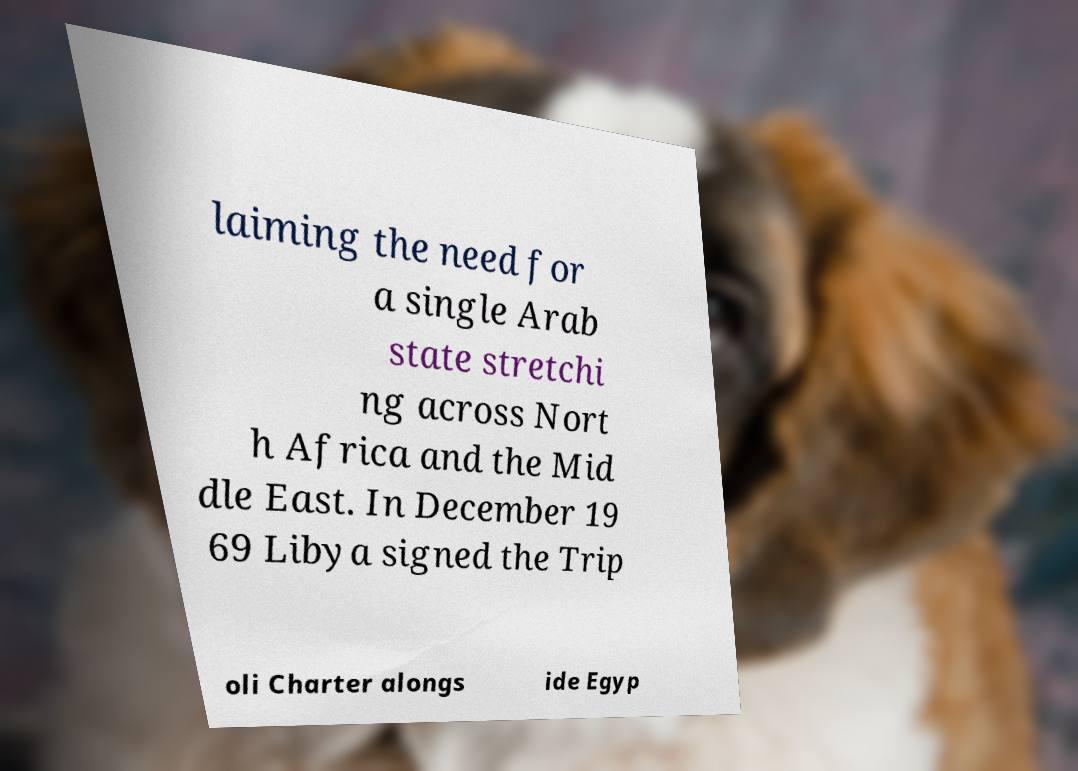What messages or text are displayed in this image? I need them in a readable, typed format. laiming the need for a single Arab state stretchi ng across Nort h Africa and the Mid dle East. In December 19 69 Libya signed the Trip oli Charter alongs ide Egyp 